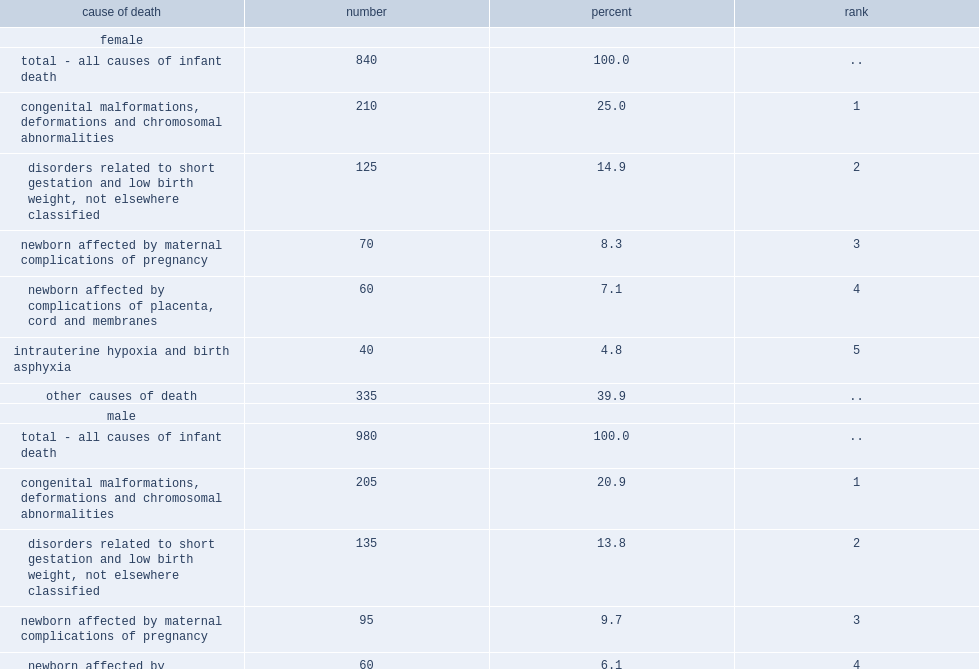What is the most common cause of infant death for both genders? 210. What is the percentage of infant girls died for congenital malformations, deformations and chromosomal abnormalities? 25.0. What is the percentage of infant boys died for congenital malformations, deformations and chromosomal abnormalities? 20.9. What is the percentage of infant girls died for disorders related to short gestation and low birth weight? 14.9. What is the percentage of infant girls died for newborn affected by maternal complications of pregnancy? 8.3. What is the percentage of infant girls died for newborn affected by complications of placenta, cord and membranes? 7.1. What is the percentage of infant girls died for intrauterine hypoxia and birth asphyxia? 4.8. What is the percentage of infant girls died for disorders related to short gestation and low birth weight? 13.8. What is the percentage of infant girls died for newborn affected by maternal complications of pregnancy? 9.7. What is the percentage of infant girls died for newborn affected by complications of placenta, cord and membranes? 6.1. What is the percentage of infant girls died for intrauterine hypoxia and birth asphyxia? 3.1. 